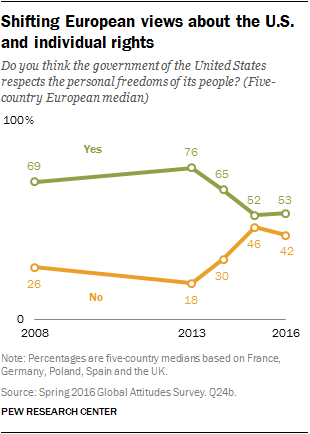Indicate a few pertinent items in this graphic. The positive view reached its peak in 2013. The gap between two views reaches its largest size in 2013. 